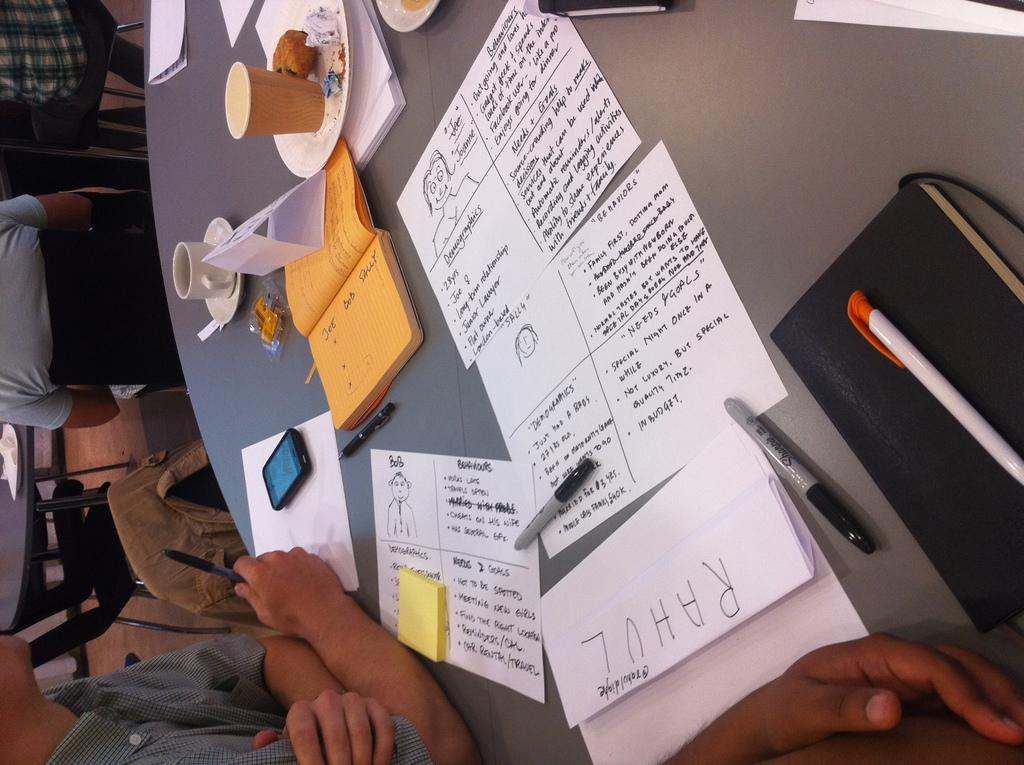What type of table is in the image? There is a round table in the image. What items can be seen on the table? Papers, cups and saucers, books, a mobile phone, and a pen are on the table. What is the person in the image doing? The presence of papers, books, and a pen suggests that the person might be working or studying. What type of muscle is visible on the person's arm in the image? There is no muscle visible on the person's arm in the image. How many teeth can be seen in the person's smile in the image? There is no person smiling in the image, and therefore no teeth are visible. 